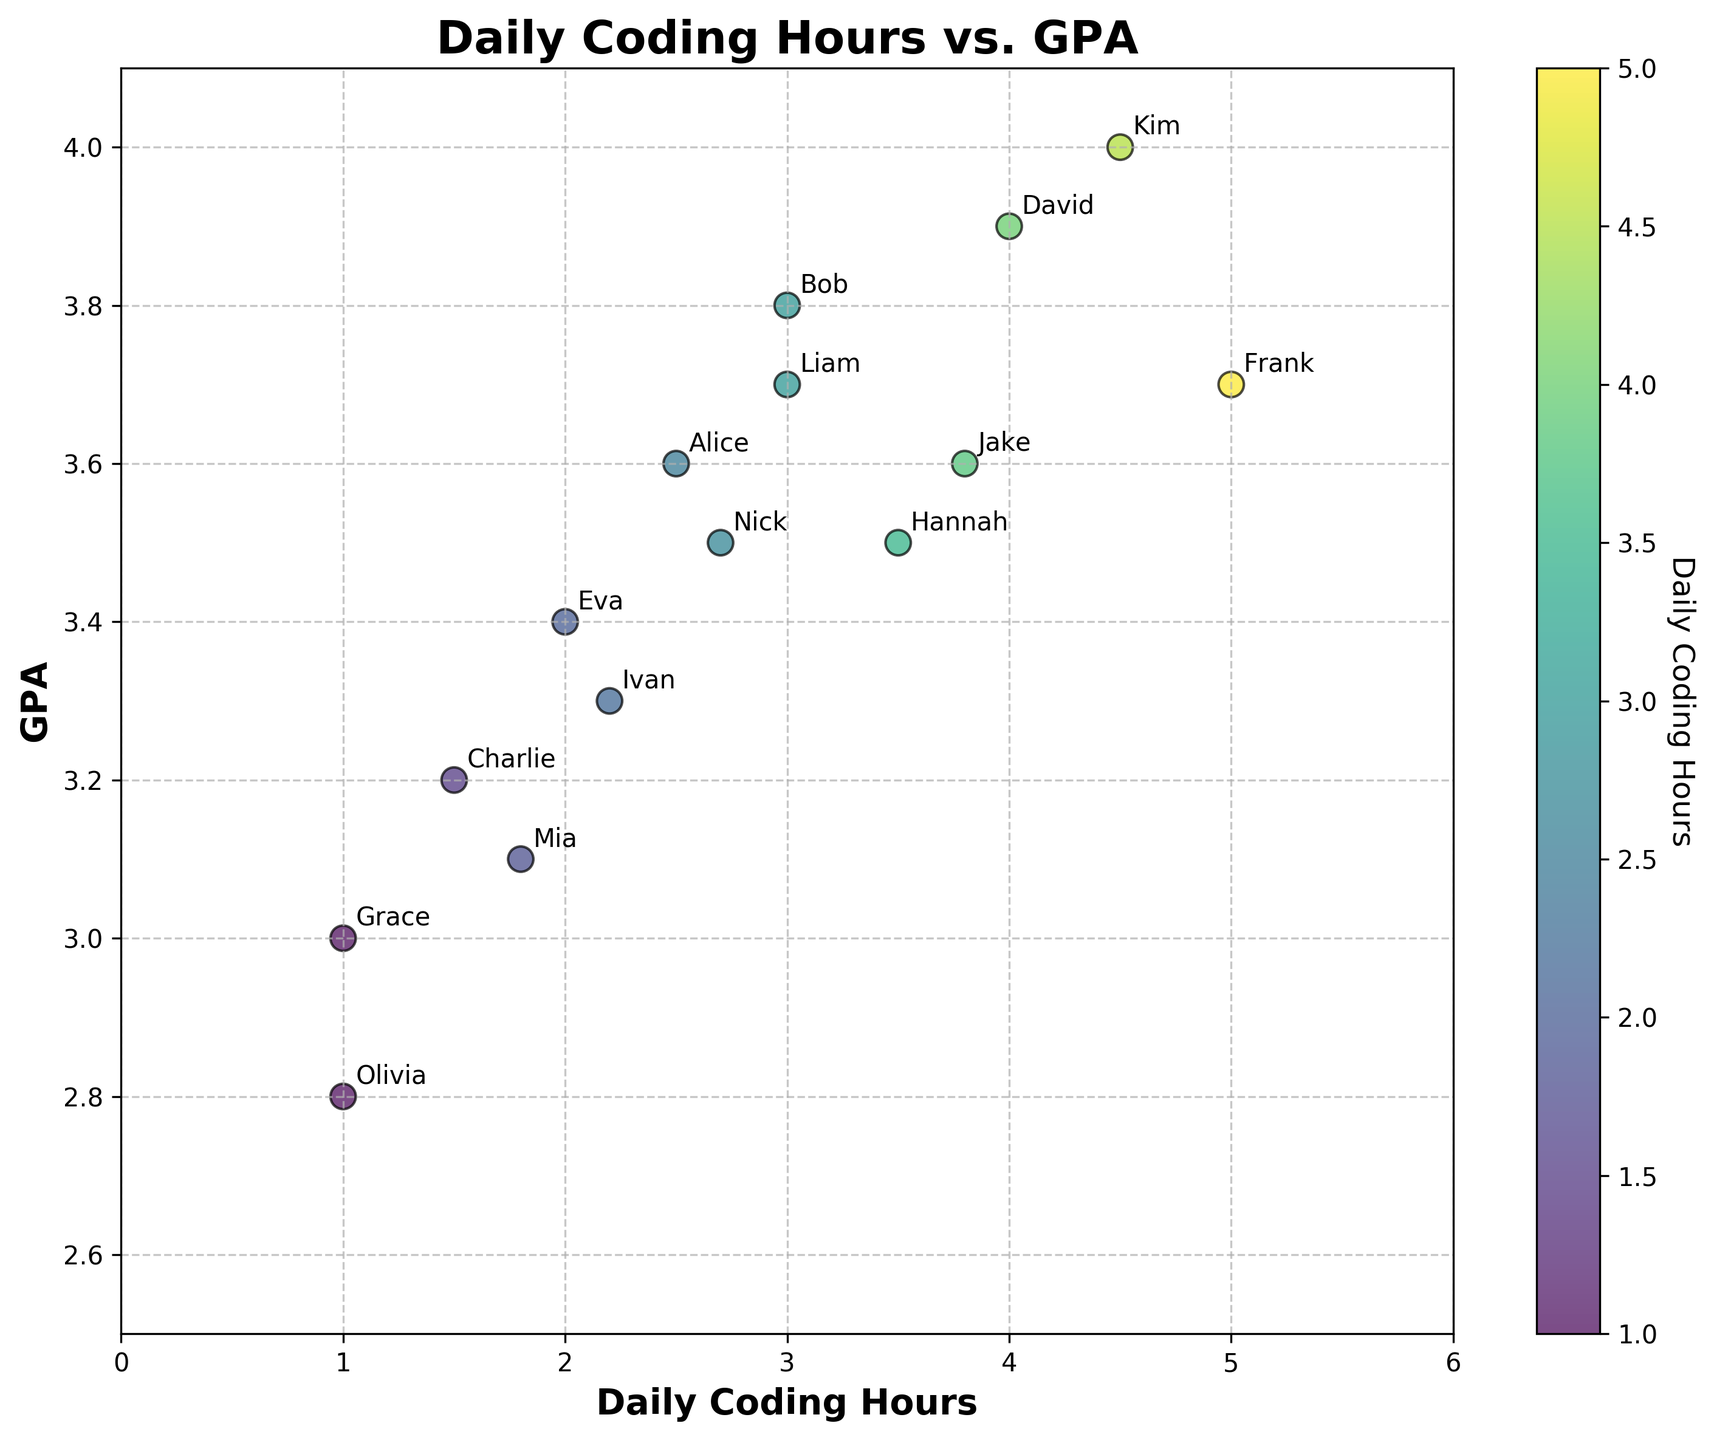What's the title of the plot? The title of the plot is displayed at the top-center of the figure. By looking at the figure, you can directly see the title.
Answer: Daily Coding Hours vs. GPA What are the labels for the x and y axes? The labels for the axes are located along the lines of the x and y axes. The x-axis label can be found below the axis, and the y-axis label can be found beside the vertical axis.
Answer: Daily Coding Hours (x), GPA (y) How many students are plotted in the figure? To determine the number of students plotted, count the number of data points or annotations in the scatter plot. There is one point per student in the plot.
Answer: 15 Which student spends the most time coding daily, and what is their GPA? Find the data point with the highest x-value (Daily Coding Hours) on the scatter plot. The annotation near this point will indicate the student's name, and the y-value (GPA) will indicate their GPA.
Answer: Frank, 3.7 What's the range of Daily Coding Hours shown in the plot? The range of Daily Coding Hours can be determined by finding the minimum and maximum values along the x-axis. The plot shows the lower and upper bounds.
Answer: 0 to 6 Which student has the highest GPA, and how many hours do they code daily? Look for the data point with the maximum y-value (GPA). The annotation near this point will indicate the student's name, and the x-value (Daily Coding Hours) will show their coding hours.
Answer: Kim, 4.5 What is the average GPA of students coding 3.0 hours daily? Identify the students who code exactly 3.0 hours daily. There are two such data points. Summing their GPAs and dividing by the number of students gives the average GPA.
Answer: (3.8 + 3.7) / 2 = 3.75 Which student who codes less than 2.0 hours daily has the highest GPA? Identify data points with x-values (Daily Coding Hours) less than 2.0. Among these points, find the one with the highest y-value (GPA) and note the student's name.
Answer: Charlie, 3.2 What is the overall trend in the relationship between Daily Coding Hours and GPA? Observe the overall pattern in the scatter plot points. Determine whether there is a positive, negative, or no clear relationship between the x-values (Daily Coding Hours) and y-values (GPA).
Answer: Positive correlation 